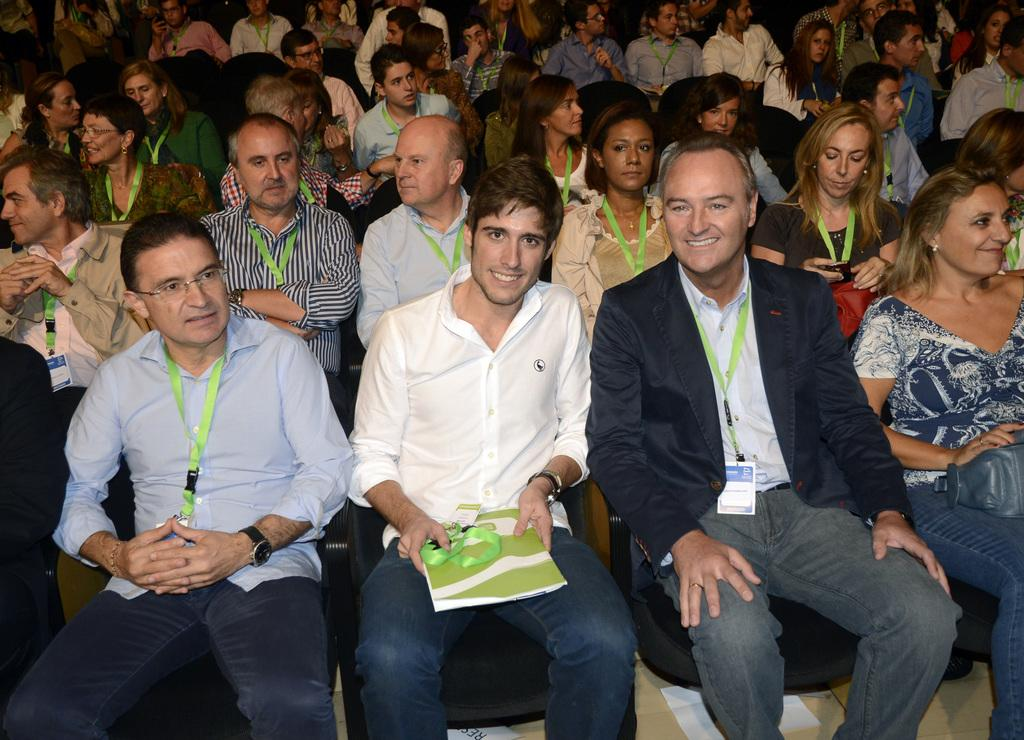How many people are in the image? There are people in the image. What are the people wearing? The people are wearing clothes. What are the people doing in the image? The people are sitting on chairs. Can you describe the person in the middle of the image? The person in the middle is holding a book with his hands. What type of cord is the person in the middle using to hold the book? There is no cord present in the image; the person is holding the book with his hands. 